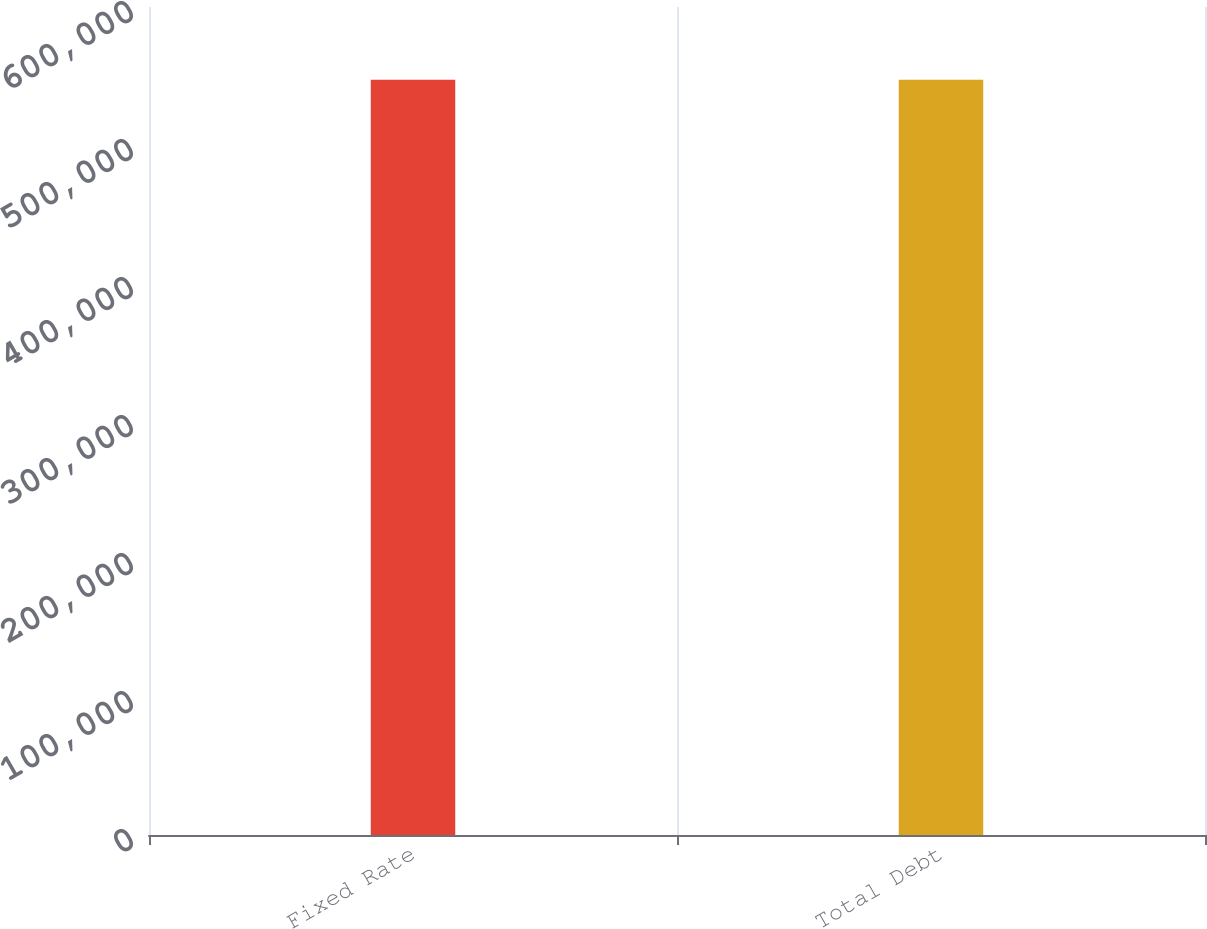<chart> <loc_0><loc_0><loc_500><loc_500><bar_chart><fcel>Fixed Rate<fcel>Total Debt<nl><fcel>547210<fcel>547210<nl></chart> 